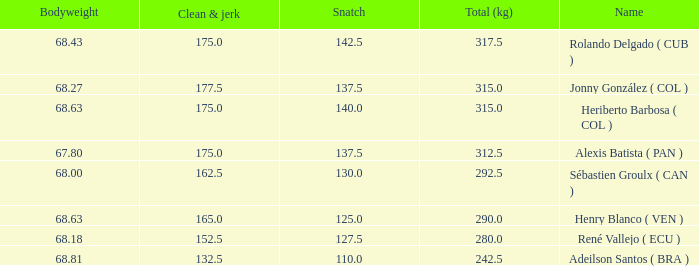Tell me the total number of snatches for clean and jerk more than 132.5 when the total kg was 315 and bodyweight was 68.63 1.0. 